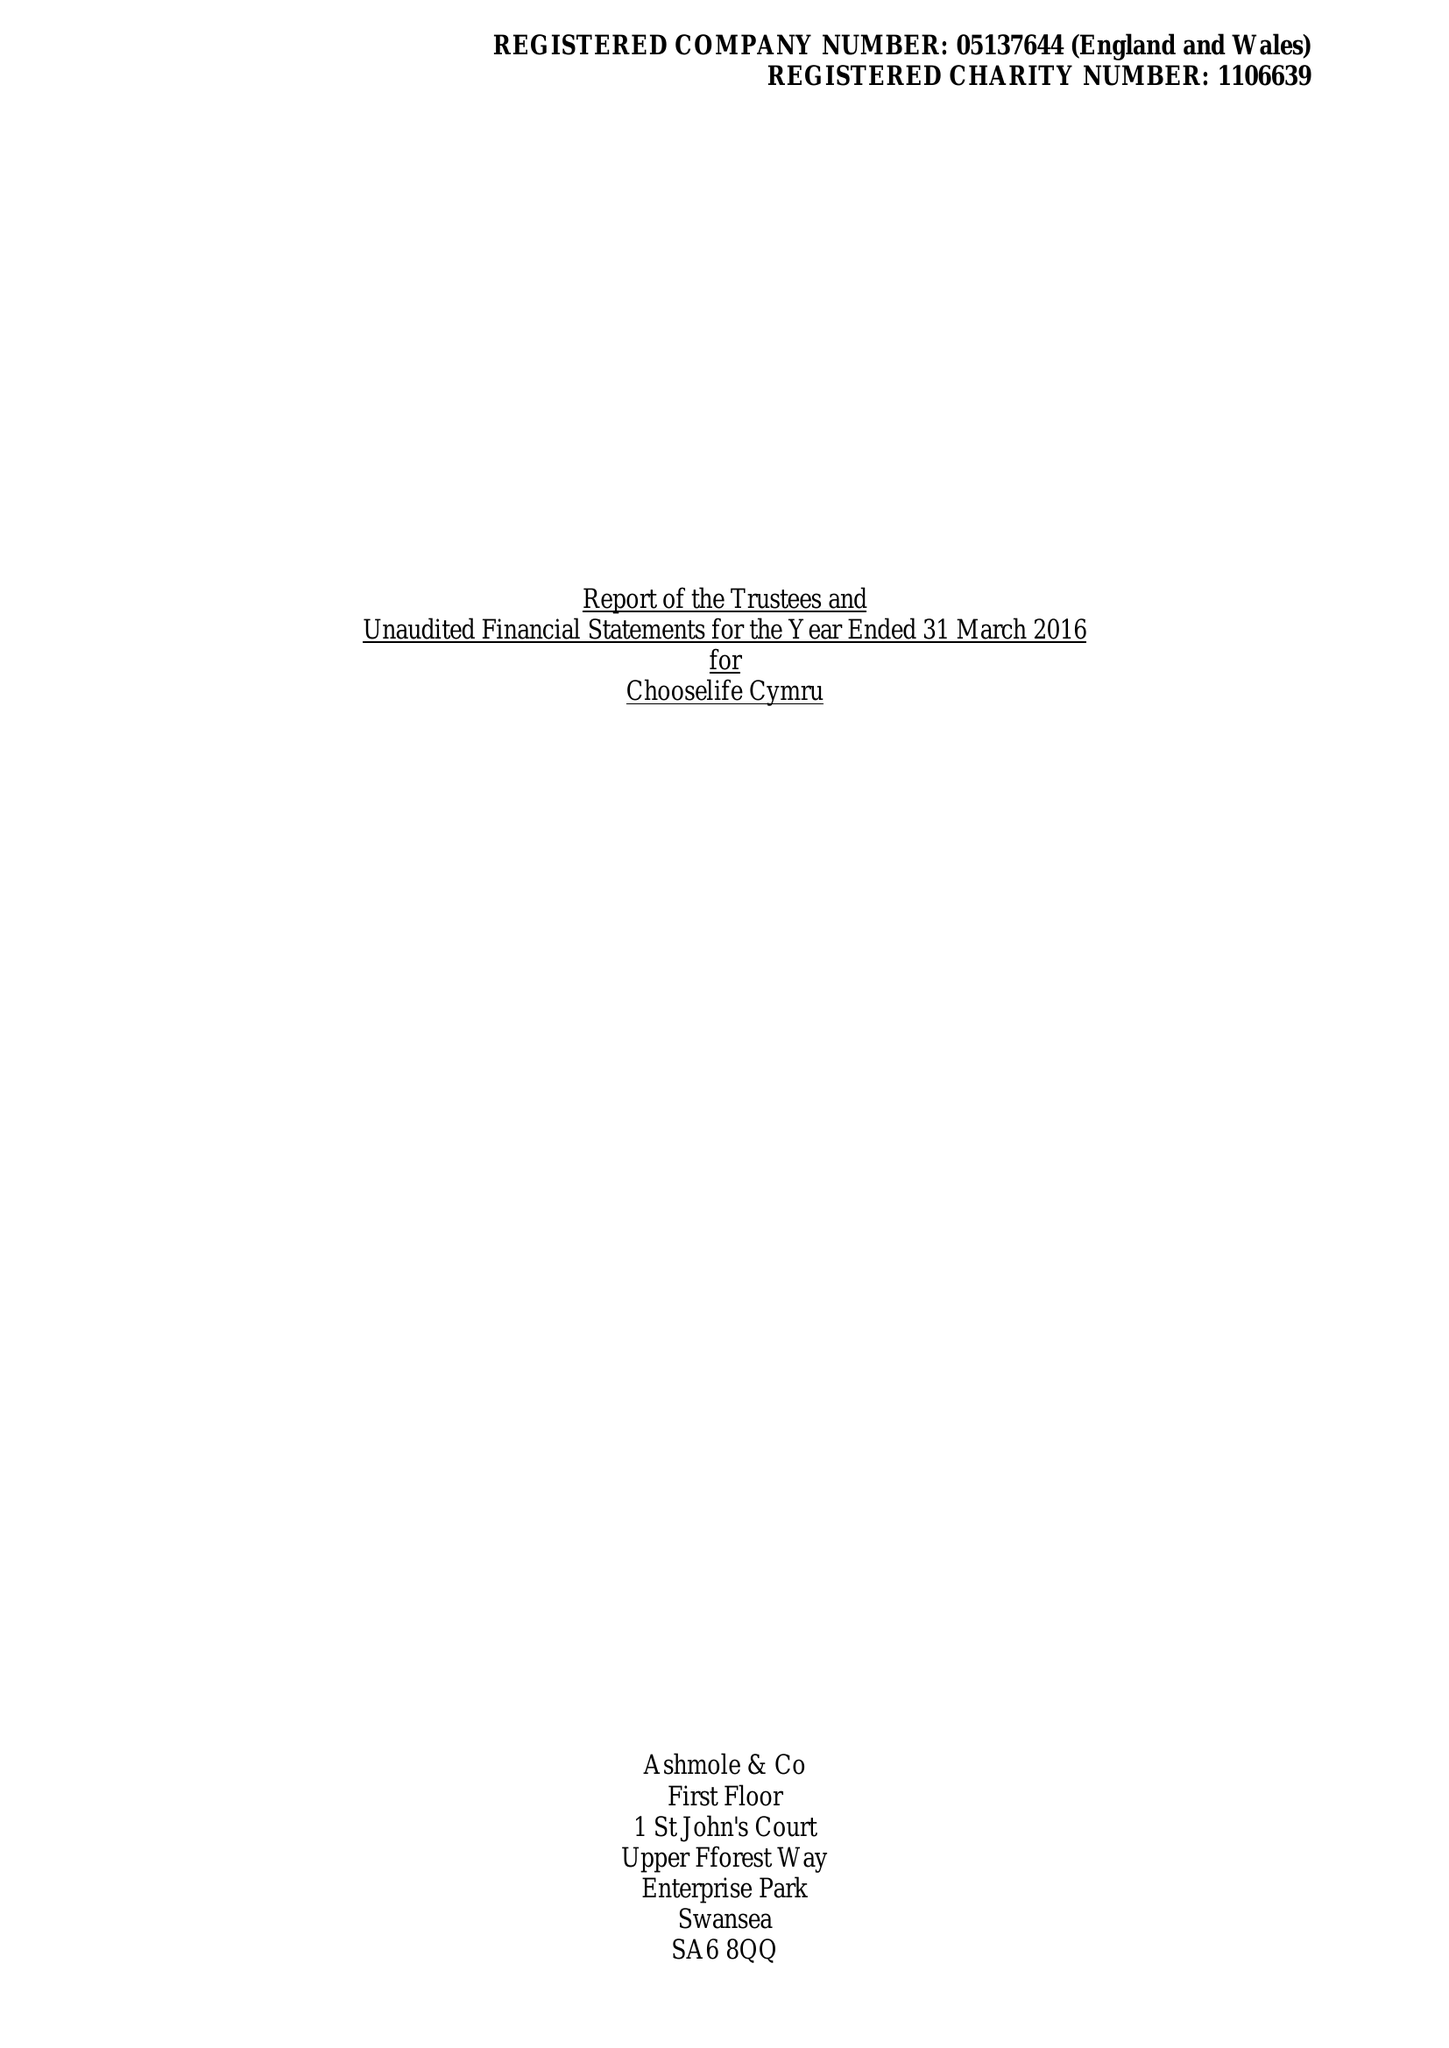What is the value for the charity_number?
Answer the question using a single word or phrase. 1106639 